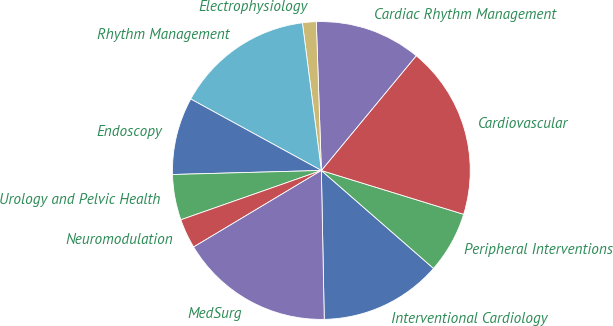Convert chart. <chart><loc_0><loc_0><loc_500><loc_500><pie_chart><fcel>Interventional Cardiology<fcel>Peripheral Interventions<fcel>Cardiovascular<fcel>Cardiac Rhythm Management<fcel>Electrophysiology<fcel>Rhythm Management<fcel>Endoscopy<fcel>Urology and Pelvic Health<fcel>Neuromodulation<fcel>MedSurg<nl><fcel>13.27%<fcel>6.67%<fcel>18.76%<fcel>11.54%<fcel>1.49%<fcel>15.0%<fcel>8.4%<fcel>4.94%<fcel>3.22%<fcel>16.72%<nl></chart> 